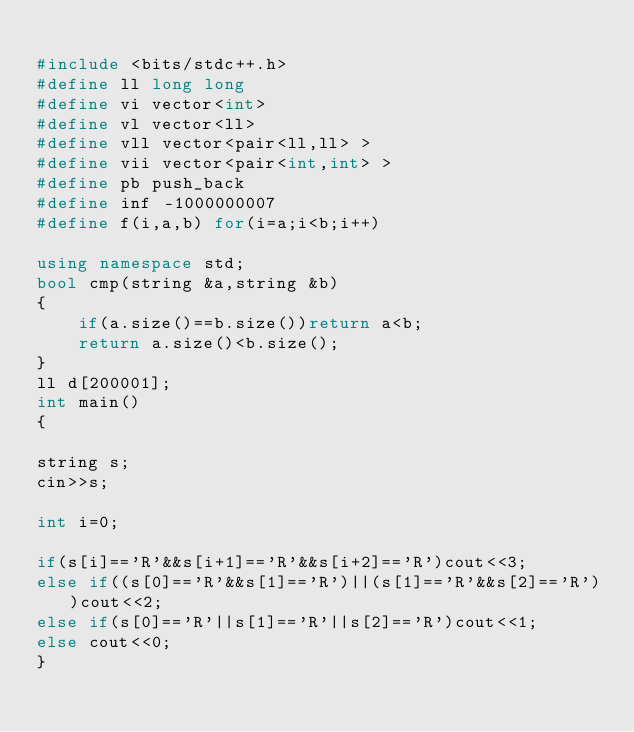Convert code to text. <code><loc_0><loc_0><loc_500><loc_500><_C++_>
#include <bits/stdc++.h>
#define ll long long 
#define vi vector<int>
#define vl vector<ll>
#define vll vector<pair<ll,ll> >
#define vii vector<pair<int,int> >
#define pb push_back
#define inf -1000000007
#define f(i,a,b) for(i=a;i<b;i++)

using namespace std;
bool cmp(string &a,string &b)
{
	if(a.size()==b.size())return a<b;
	return a.size()<b.size();
}
ll d[200001];
int main()
{
	
string s;
cin>>s;

int i=0;

if(s[i]=='R'&&s[i+1]=='R'&&s[i+2]=='R')cout<<3;
else if((s[0]=='R'&&s[1]=='R')||(s[1]=='R'&&s[2]=='R'))cout<<2;
else if(s[0]=='R'||s[1]=='R'||s[2]=='R')cout<<1;
else cout<<0;
}</code> 